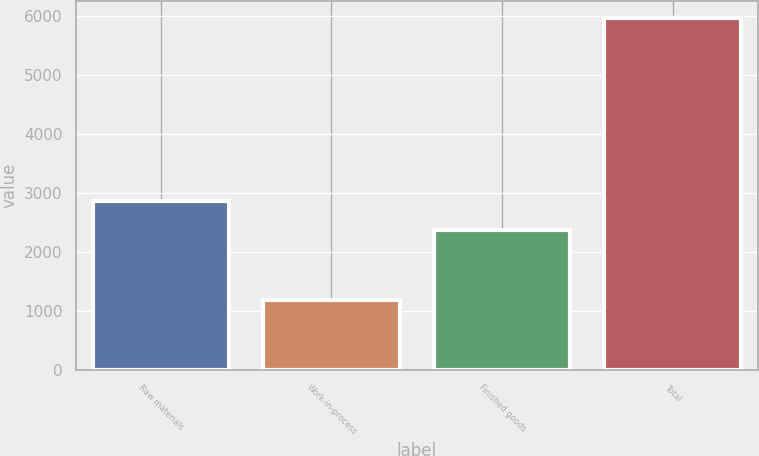<chart> <loc_0><loc_0><loc_500><loc_500><bar_chart><fcel>Raw materials<fcel>Work-in-process<fcel>Finished goods<fcel>Total<nl><fcel>2857.3<fcel>1183<fcel>2379<fcel>5966<nl></chart> 